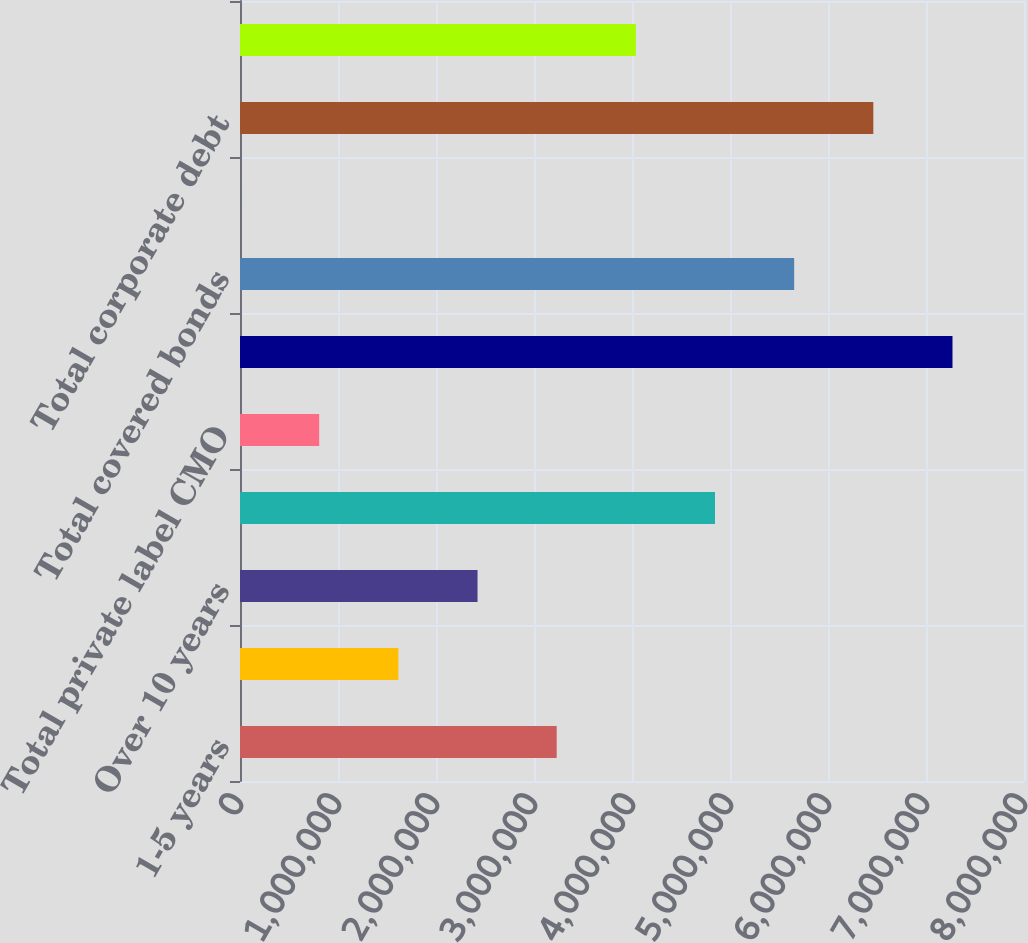Convert chart. <chart><loc_0><loc_0><loc_500><loc_500><bar_chart><fcel>1-5 years<fcel>6-10 years<fcel>Over 10 years<fcel>Total municipal securities<fcel>Total private label CMO<fcel>Total asset-backed securities<fcel>Total covered bonds<fcel>Under 1 year<fcel>Total corporate debt<fcel>Nonmarketable equity<nl><fcel>3.23152e+06<fcel>1.61602e+06<fcel>2.42377e+06<fcel>4.84702e+06<fcel>808268<fcel>7.27026e+06<fcel>5.65477e+06<fcel>518<fcel>6.46251e+06<fcel>4.03927e+06<nl></chart> 